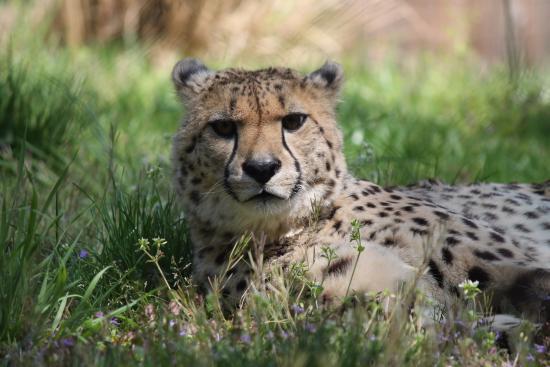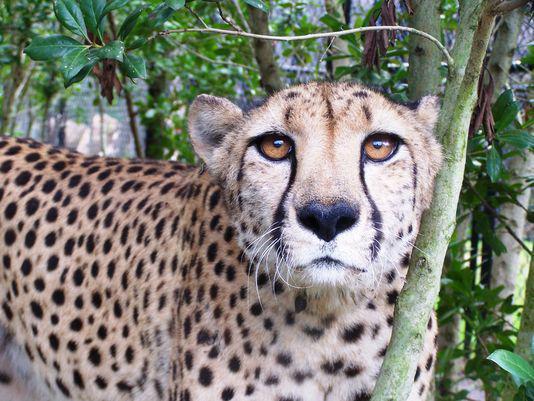The first image is the image on the left, the second image is the image on the right. Evaluate the accuracy of this statement regarding the images: "There are 3 cheetahs.". Is it true? Answer yes or no. No. The first image is the image on the left, the second image is the image on the right. Analyze the images presented: Is the assertion "There are two leopards in one of the images." valid? Answer yes or no. No. 